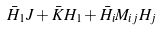Convert formula to latex. <formula><loc_0><loc_0><loc_500><loc_500>\bar { H } _ { 1 } J + \bar { K } H _ { 1 } + \bar { H } _ { i } M _ { i j } H _ { j }</formula> 